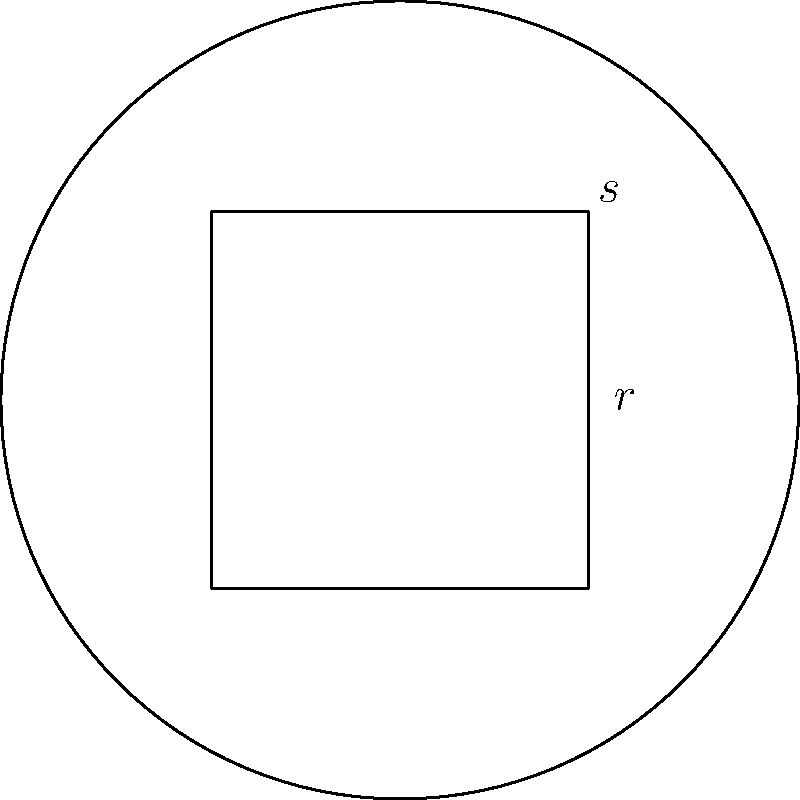As you prepare for your first prayer session in the seminary, you notice a unique circular prayer rug with a square design in the center. The circular rug has a radius of 3 feet, and the square design has a side length of 2$\sqrt{2}$ feet. Calculate the area of the prayer rug that is not covered by the square design. Round your answer to two decimal places. Let's approach this step-by-step:

1) First, calculate the area of the entire circular rug:
   $A_{circle} = \pi r^2 = \pi (3^2) = 9\pi$ sq ft

2) Now, calculate the area of the square design:
   $A_{square} = s^2 = (2\sqrt{2})^2 = 8$ sq ft

3) The area we're looking for is the difference between these two:
   $A_{result} = A_{circle} - A_{square} = 9\pi - 8$ sq ft

4) Let's calculate this:
   $9\pi - 8 \approx 28.27 - 8 = 20.27$ sq ft

5) Rounding to two decimal places:
   $20.27$ sq ft

Therefore, the area of the prayer rug not covered by the square design is approximately 20.27 square feet.
Answer: 20.27 sq ft 